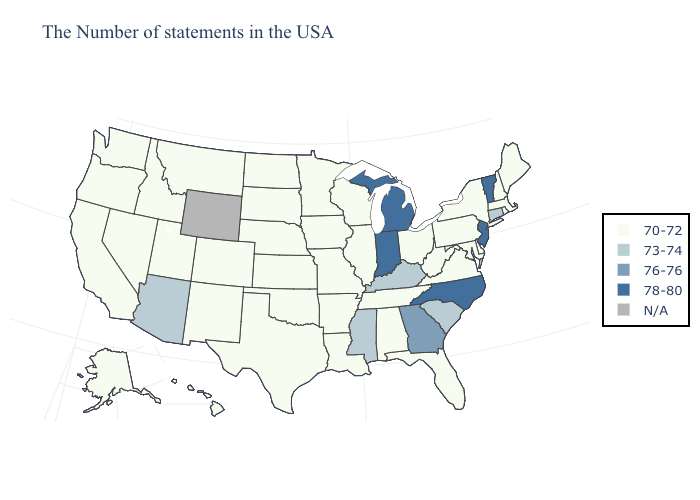Name the states that have a value in the range N/A?
Write a very short answer. Wyoming. What is the value of Rhode Island?
Quick response, please. 70-72. What is the highest value in the Northeast ?
Quick response, please. 78-80. What is the highest value in the Northeast ?
Short answer required. 78-80. Among the states that border New Hampshire , does Maine have the highest value?
Concise answer only. No. What is the lowest value in the USA?
Concise answer only. 70-72. Name the states that have a value in the range N/A?
Be succinct. Wyoming. Name the states that have a value in the range 73-74?
Keep it brief. Connecticut, South Carolina, Kentucky, Mississippi, Arizona. What is the highest value in states that border West Virginia?
Give a very brief answer. 73-74. Which states have the lowest value in the Northeast?
Answer briefly. Maine, Massachusetts, Rhode Island, New Hampshire, New York, Pennsylvania. Name the states that have a value in the range 76-76?
Give a very brief answer. Georgia. Name the states that have a value in the range N/A?
Be succinct. Wyoming. Among the states that border Nevada , which have the lowest value?
Concise answer only. Utah, Idaho, California, Oregon. What is the lowest value in the Northeast?
Concise answer only. 70-72. 